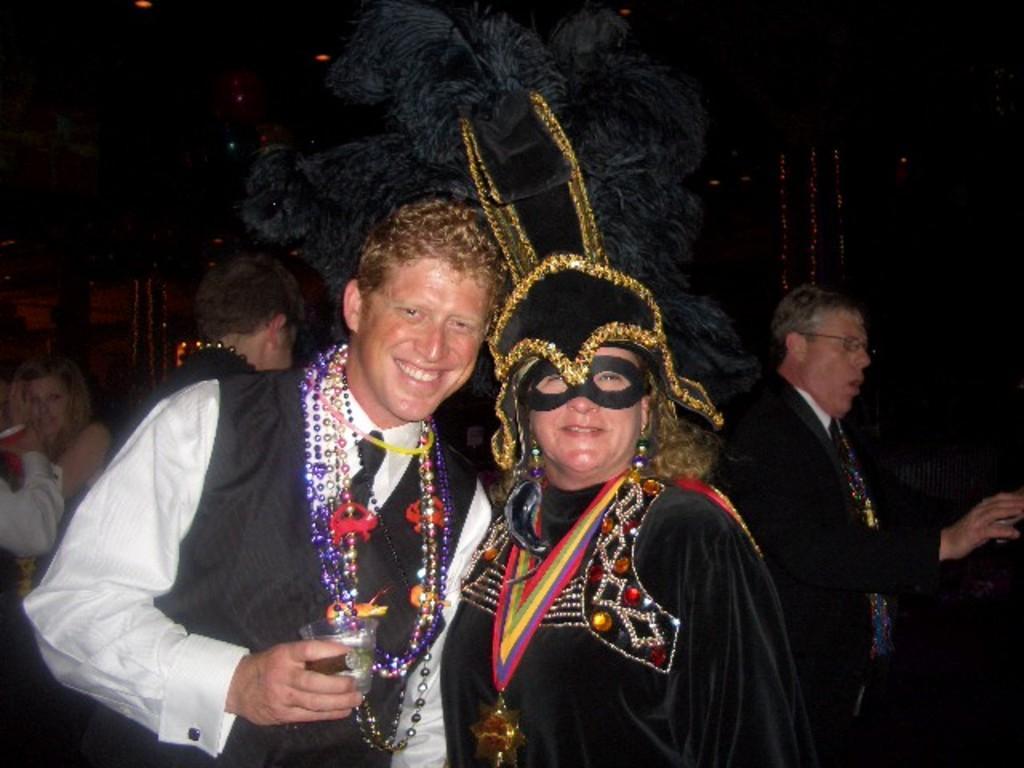Please provide a concise description of this image. In this image, there are group of people wearing clothes. The person who is at the bottom of the image wearing a mask. 